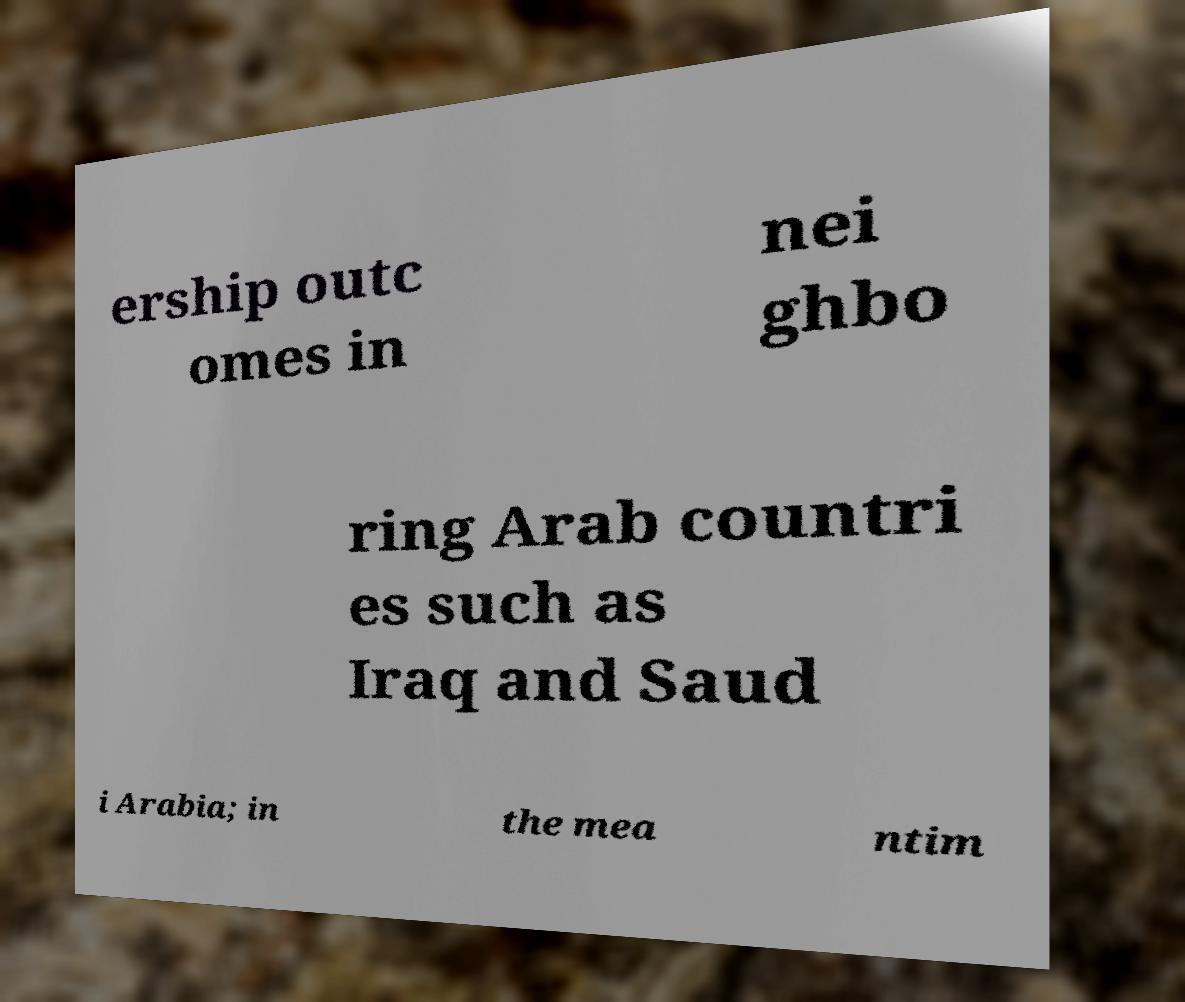What messages or text are displayed in this image? I need them in a readable, typed format. ership outc omes in nei ghbo ring Arab countri es such as Iraq and Saud i Arabia; in the mea ntim 